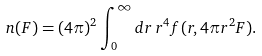<formula> <loc_0><loc_0><loc_500><loc_500>n ( F ) = ( 4 \pi ) ^ { 2 } \int _ { 0 } ^ { \infty } d r \, r ^ { 4 } f ( r , 4 \pi r ^ { 2 } F ) .</formula> 